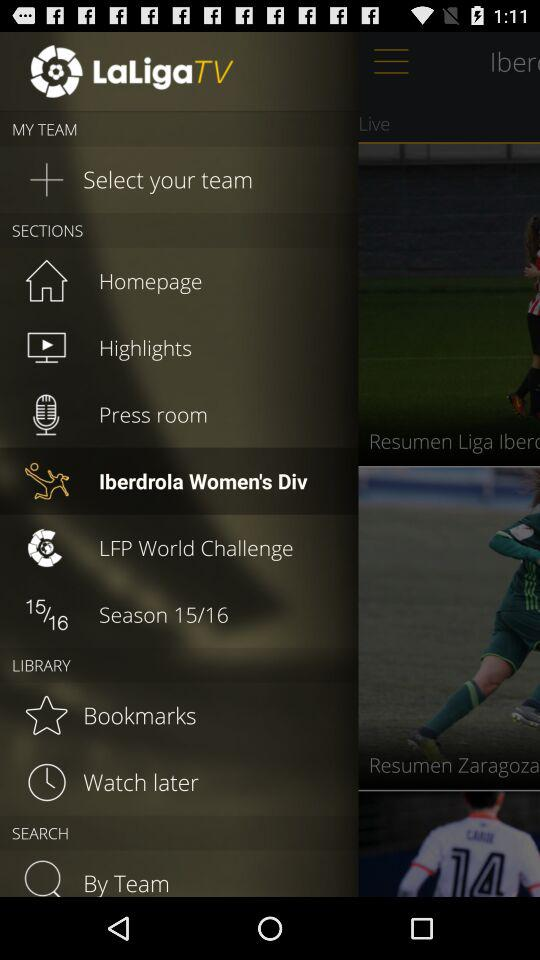What season is mentioned in "LaLigaTV"? The mentioned season is from 2015 to 2016. 